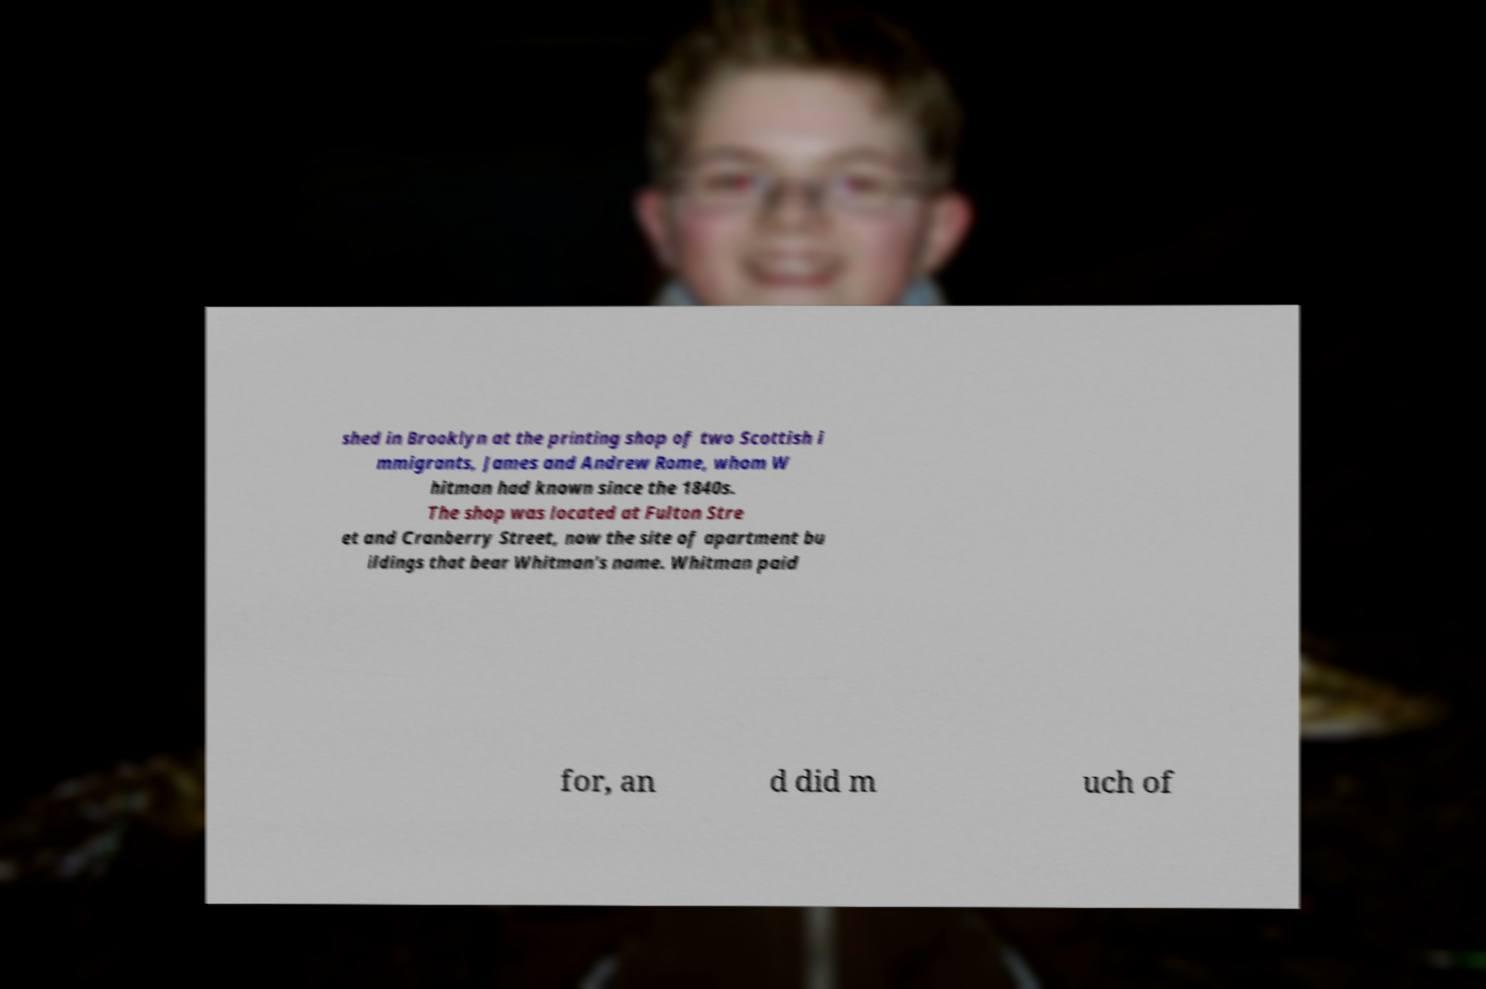What messages or text are displayed in this image? I need them in a readable, typed format. shed in Brooklyn at the printing shop of two Scottish i mmigrants, James and Andrew Rome, whom W hitman had known since the 1840s. The shop was located at Fulton Stre et and Cranberry Street, now the site of apartment bu ildings that bear Whitman's name. Whitman paid for, an d did m uch of 